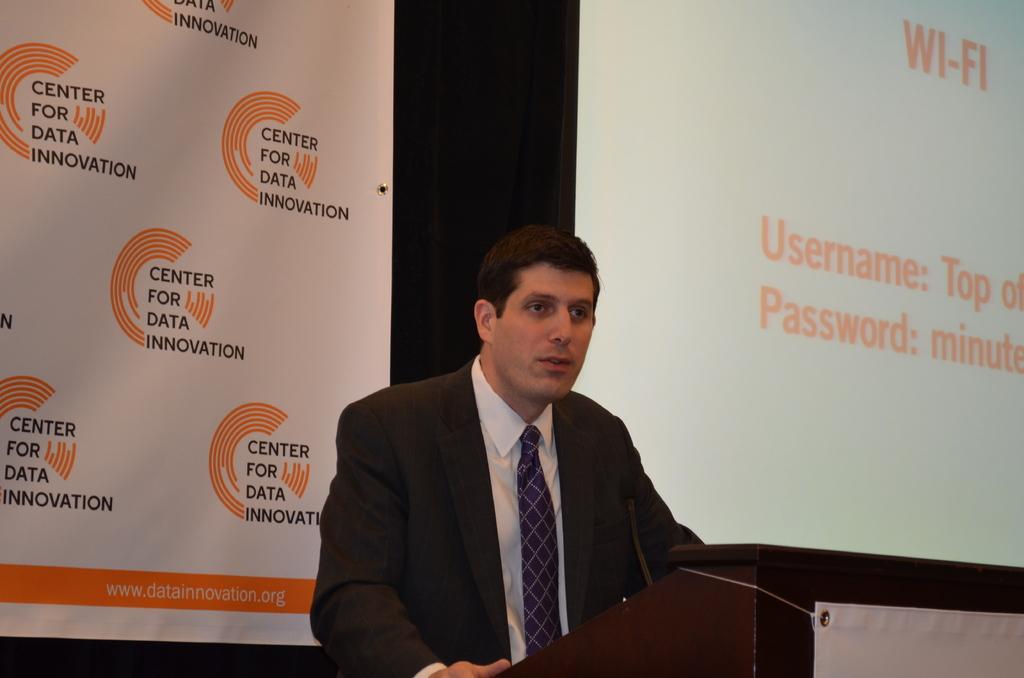In one or two sentences, can you explain what this image depicts? In the foreground of this image, there is a man standing in front of a podium on which there is a mic and at the bottom right, there is a banner to the podium. In the background, there is a banner and a screen. 